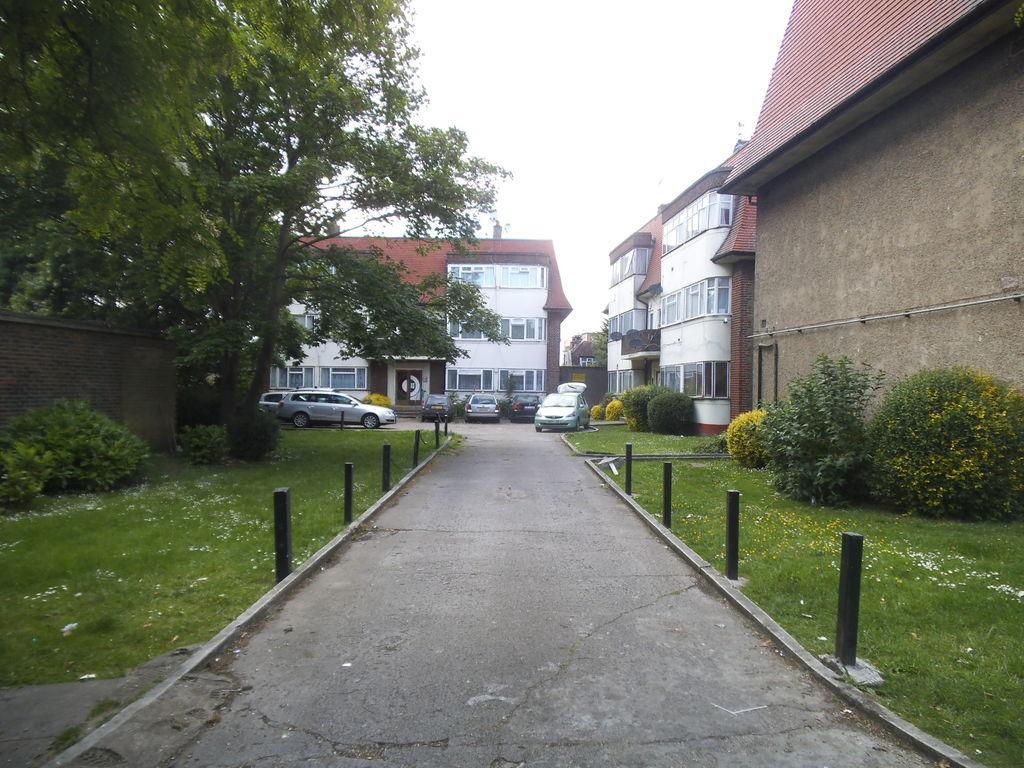Describe this image in one or two sentences. In this picture there are glass land and plants on the right and left side of the image and there are houses and trees in the center of the image. 